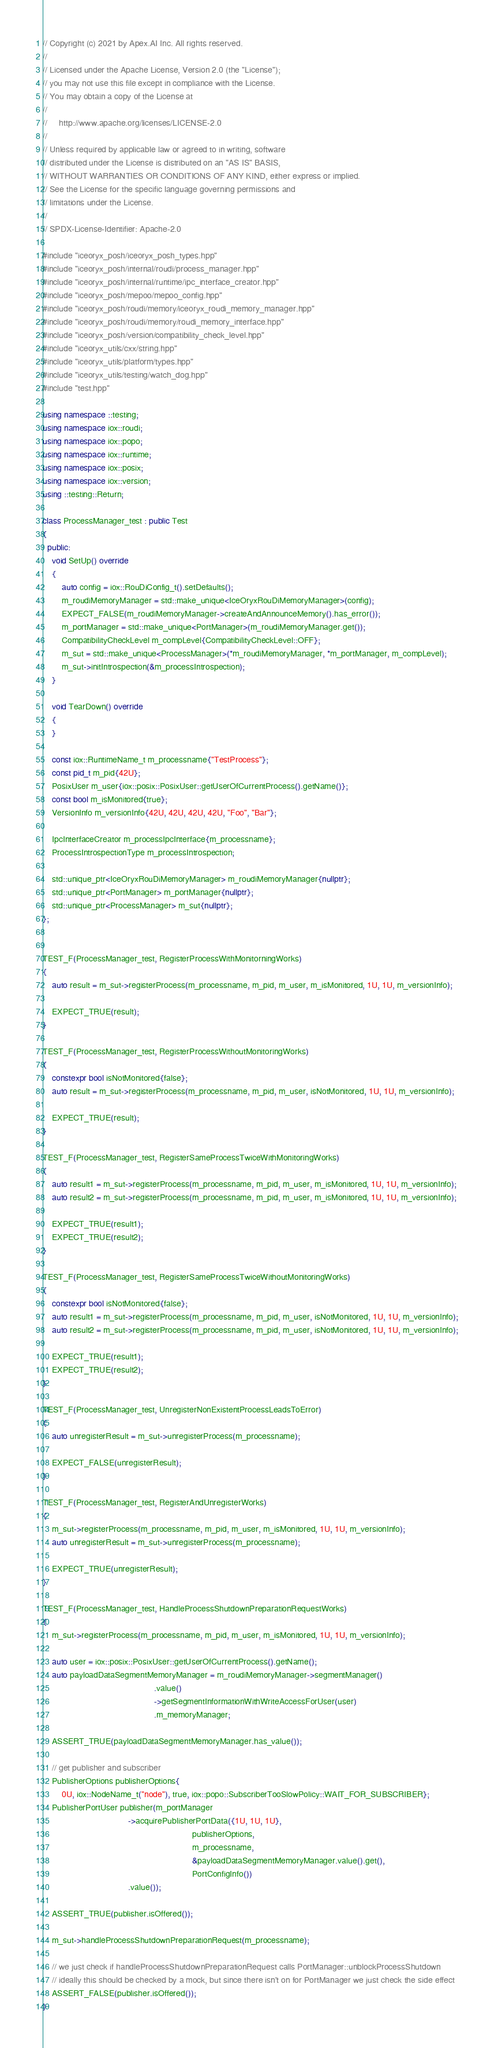<code> <loc_0><loc_0><loc_500><loc_500><_C++_>// Copyright (c) 2021 by Apex.AI Inc. All rights reserved.
//
// Licensed under the Apache License, Version 2.0 (the "License");
// you may not use this file except in compliance with the License.
// You may obtain a copy of the License at
//
//     http://www.apache.org/licenses/LICENSE-2.0
//
// Unless required by applicable law or agreed to in writing, software
// distributed under the License is distributed on an "AS IS" BASIS,
// WITHOUT WARRANTIES OR CONDITIONS OF ANY KIND, either express or implied.
// See the License for the specific language governing permissions and
// limitations under the License.
//
// SPDX-License-Identifier: Apache-2.0

#include "iceoryx_posh/iceoryx_posh_types.hpp"
#include "iceoryx_posh/internal/roudi/process_manager.hpp"
#include "iceoryx_posh/internal/runtime/ipc_interface_creator.hpp"
#include "iceoryx_posh/mepoo/mepoo_config.hpp"
#include "iceoryx_posh/roudi/memory/iceoryx_roudi_memory_manager.hpp"
#include "iceoryx_posh/roudi/memory/roudi_memory_interface.hpp"
#include "iceoryx_posh/version/compatibility_check_level.hpp"
#include "iceoryx_utils/cxx/string.hpp"
#include "iceoryx_utils/platform/types.hpp"
#include "iceoryx_utils/testing/watch_dog.hpp"
#include "test.hpp"

using namespace ::testing;
using namespace iox::roudi;
using namespace iox::popo;
using namespace iox::runtime;
using namespace iox::posix;
using namespace iox::version;
using ::testing::Return;

class ProcessManager_test : public Test
{
  public:
    void SetUp() override
    {
        auto config = iox::RouDiConfig_t().setDefaults();
        m_roudiMemoryManager = std::make_unique<IceOryxRouDiMemoryManager>(config);
        EXPECT_FALSE(m_roudiMemoryManager->createAndAnnounceMemory().has_error());
        m_portManager = std::make_unique<PortManager>(m_roudiMemoryManager.get());
        CompatibilityCheckLevel m_compLevel{CompatibilityCheckLevel::OFF};
        m_sut = std::make_unique<ProcessManager>(*m_roudiMemoryManager, *m_portManager, m_compLevel);
        m_sut->initIntrospection(&m_processIntrospection);
    }

    void TearDown() override
    {
    }

    const iox::RuntimeName_t m_processname{"TestProcess"};
    const pid_t m_pid{42U};
    PosixUser m_user{iox::posix::PosixUser::getUserOfCurrentProcess().getName()};
    const bool m_isMonitored{true};
    VersionInfo m_versionInfo{42U, 42U, 42U, 42U, "Foo", "Bar"};

    IpcInterfaceCreator m_processIpcInterface{m_processname};
    ProcessIntrospectionType m_processIntrospection;

    std::unique_ptr<IceOryxRouDiMemoryManager> m_roudiMemoryManager{nullptr};
    std::unique_ptr<PortManager> m_portManager{nullptr};
    std::unique_ptr<ProcessManager> m_sut{nullptr};
};


TEST_F(ProcessManager_test, RegisterProcessWithMonitorningWorks)
{
    auto result = m_sut->registerProcess(m_processname, m_pid, m_user, m_isMonitored, 1U, 1U, m_versionInfo);

    EXPECT_TRUE(result);
}

TEST_F(ProcessManager_test, RegisterProcessWithoutMonitoringWorks)
{
    constexpr bool isNotMonitored{false};
    auto result = m_sut->registerProcess(m_processname, m_pid, m_user, isNotMonitored, 1U, 1U, m_versionInfo);

    EXPECT_TRUE(result);
}

TEST_F(ProcessManager_test, RegisterSameProcessTwiceWithMonitoringWorks)
{
    auto result1 = m_sut->registerProcess(m_processname, m_pid, m_user, m_isMonitored, 1U, 1U, m_versionInfo);
    auto result2 = m_sut->registerProcess(m_processname, m_pid, m_user, m_isMonitored, 1U, 1U, m_versionInfo);

    EXPECT_TRUE(result1);
    EXPECT_TRUE(result2);
}

TEST_F(ProcessManager_test, RegisterSameProcessTwiceWithoutMonitoringWorks)
{
    constexpr bool isNotMonitored{false};
    auto result1 = m_sut->registerProcess(m_processname, m_pid, m_user, isNotMonitored, 1U, 1U, m_versionInfo);
    auto result2 = m_sut->registerProcess(m_processname, m_pid, m_user, isNotMonitored, 1U, 1U, m_versionInfo);

    EXPECT_TRUE(result1);
    EXPECT_TRUE(result2);
}

TEST_F(ProcessManager_test, UnregisterNonExistentProcessLeadsToError)
{
    auto unregisterResult = m_sut->unregisterProcess(m_processname);

    EXPECT_FALSE(unregisterResult);
}

TEST_F(ProcessManager_test, RegisterAndUnregisterWorks)
{
    m_sut->registerProcess(m_processname, m_pid, m_user, m_isMonitored, 1U, 1U, m_versionInfo);
    auto unregisterResult = m_sut->unregisterProcess(m_processname);

    EXPECT_TRUE(unregisterResult);
}

TEST_F(ProcessManager_test, HandleProcessShutdownPreparationRequestWorks)
{
    m_sut->registerProcess(m_processname, m_pid, m_user, m_isMonitored, 1U, 1U, m_versionInfo);

    auto user = iox::posix::PosixUser::getUserOfCurrentProcess().getName();
    auto payloadDataSegmentMemoryManager = m_roudiMemoryManager->segmentManager()
                                               .value()
                                               ->getSegmentInformationWithWriteAccessForUser(user)
                                               .m_memoryManager;

    ASSERT_TRUE(payloadDataSegmentMemoryManager.has_value());

    // get publisher and subscriber
    PublisherOptions publisherOptions{
        0U, iox::NodeName_t("node"), true, iox::popo::SubscriberTooSlowPolicy::WAIT_FOR_SUBSCRIBER};
    PublisherPortUser publisher(m_portManager
                                    ->acquirePublisherPortData({1U, 1U, 1U},
                                                               publisherOptions,
                                                               m_processname,
                                                               &payloadDataSegmentMemoryManager.value().get(),
                                                               PortConfigInfo())
                                    .value());

    ASSERT_TRUE(publisher.isOffered());

    m_sut->handleProcessShutdownPreparationRequest(m_processname);

    // we just check if handleProcessShutdownPreparationRequest calls PortManager::unblockProcessShutdown
    // ideally this should be checked by a mock, but since there isn't on for PortManager we just check the side effect
    ASSERT_FALSE(publisher.isOffered());
}
</code> 